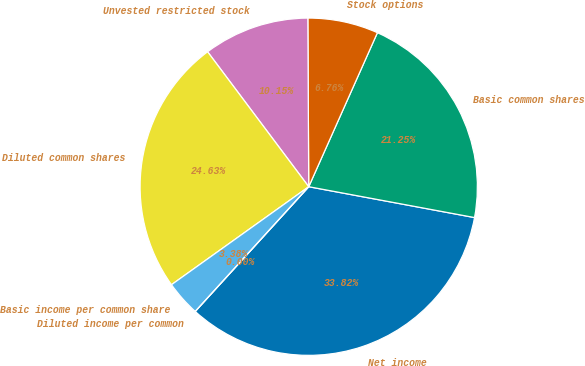<chart> <loc_0><loc_0><loc_500><loc_500><pie_chart><fcel>Net income<fcel>Basic common shares<fcel>Stock options<fcel>Unvested restricted stock<fcel>Diluted common shares<fcel>Basic income per common share<fcel>Diluted income per common<nl><fcel>33.82%<fcel>21.25%<fcel>6.76%<fcel>10.15%<fcel>24.63%<fcel>3.38%<fcel>0.0%<nl></chart> 